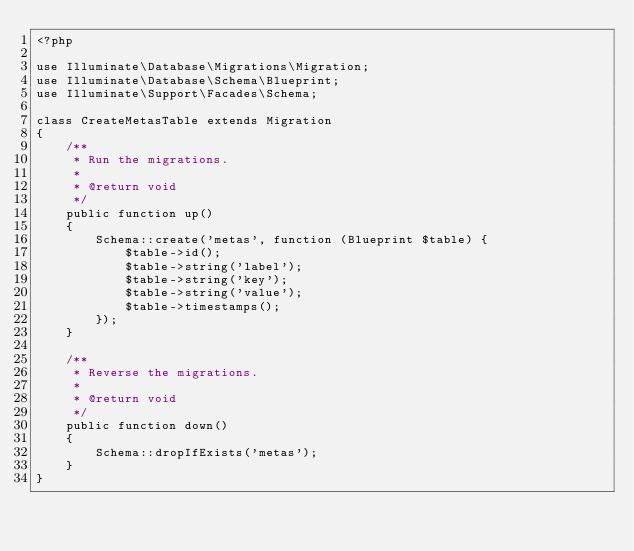<code> <loc_0><loc_0><loc_500><loc_500><_PHP_><?php

use Illuminate\Database\Migrations\Migration;
use Illuminate\Database\Schema\Blueprint;
use Illuminate\Support\Facades\Schema;

class CreateMetasTable extends Migration
{
    /**
     * Run the migrations.
     *
     * @return void
     */
    public function up()
    {
        Schema::create('metas', function (Blueprint $table) {
            $table->id();
            $table->string('label');
            $table->string('key');
            $table->string('value');
            $table->timestamps();
        });
    }

    /**
     * Reverse the migrations.
     *
     * @return void
     */
    public function down()
    {
        Schema::dropIfExists('metas');
    }
}
</code> 